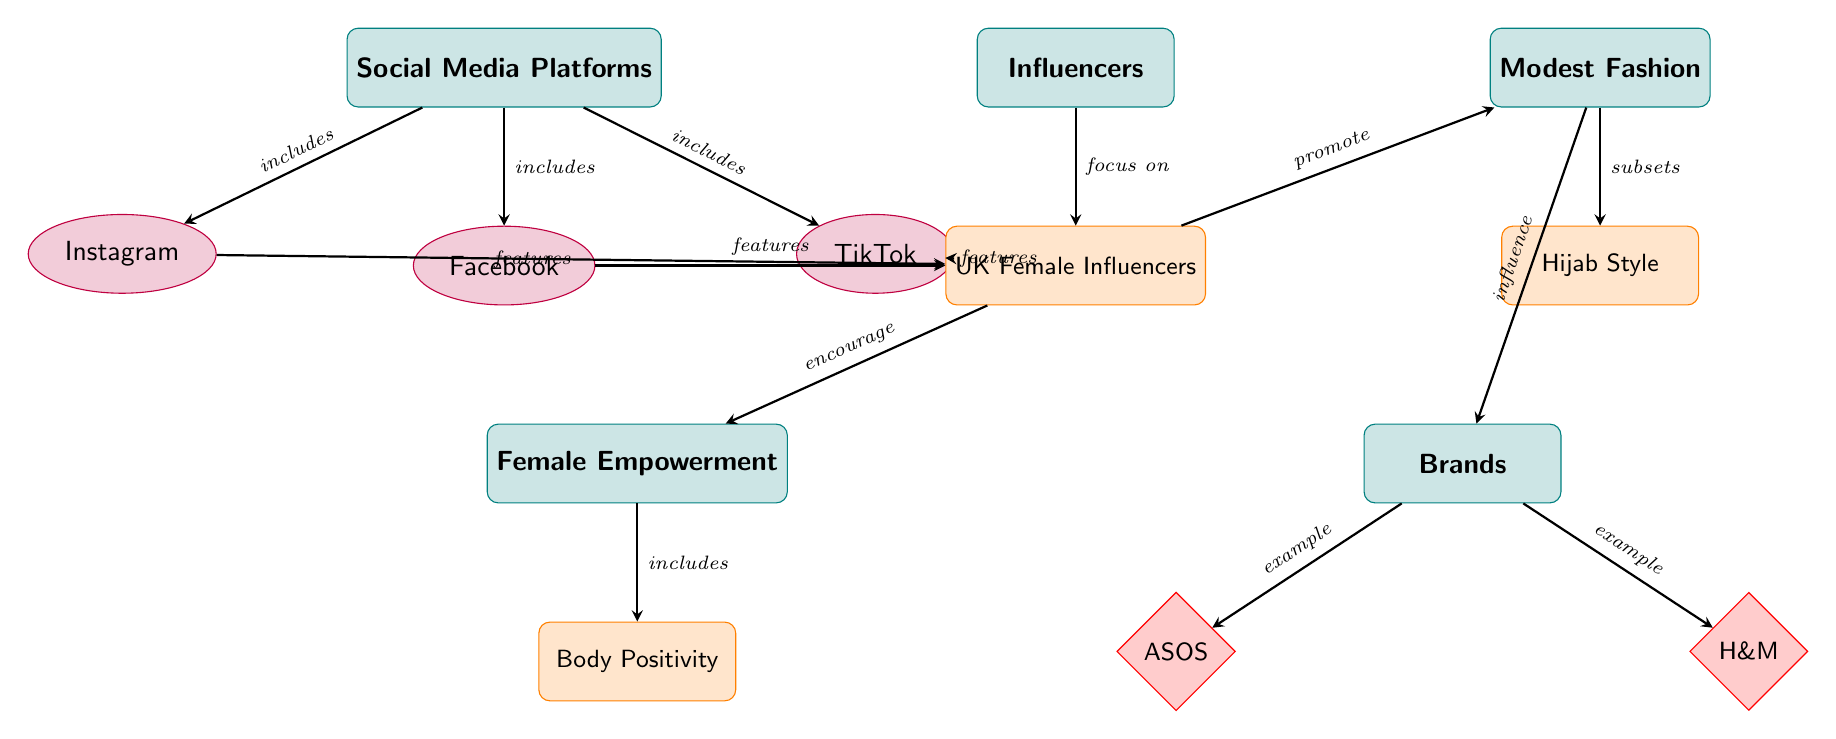What are the three social media platforms listed? The diagram identifies three social media platforms: Instagram, Facebook, and TikTok, which are represented under the category of Social Media Platforms.
Answer: Instagram, Facebook, TikTok How many brands are mentioned in the diagram? The diagram displays two brands under the Brands category: ASOS and H&M. Therefore, the total count is two brands.
Answer: 2 Which subcategory falls under modest fashion? The diagram shows Hijab Style as the only subcategory listed under the Modest Fashion category.
Answer: Hijab Style What do UK female influencers promote according to the diagram? The UK female influencers are shown to promote modest fashion as indicated by the directed edge connecting UK influencers to the modest fashion category.
Answer: Modest Fashion Which concept is included in female empowerment? The diagram indicates that Body Positivity is included as a concept within the Female Empowerment category, highlighting its relationship and relevance.
Answer: Body Positivity What is the relationship between social media platforms and UK female influencers? The diagram illustrates that each social media platform features UK female influencers, as indicated by the directed edges from the social media platforms to UK influencers.
Answer: Features How do UK female influencers encourage female empowerment? UK female influencers are depicted as encouraging female empowerment, as evidenced by the directed edge from UK influencers to the Female Empowerment category, indicating a supportive influence.
Answer: Encourage Which brand is mentioned as an example of the brands category? The brands category includes ASOS and H&M, and either of these would be correct as examples. The diagram distinctly labels these brands as examples under the Brands category.
Answer: ASOS (or H&M) What category is directly connected to Hijab Style? The diagram shows that Hijab Style is a subset under the Modest Fashion category, indicating its specific relation within the broader category of modest fashion.
Answer: Modest Fashion 